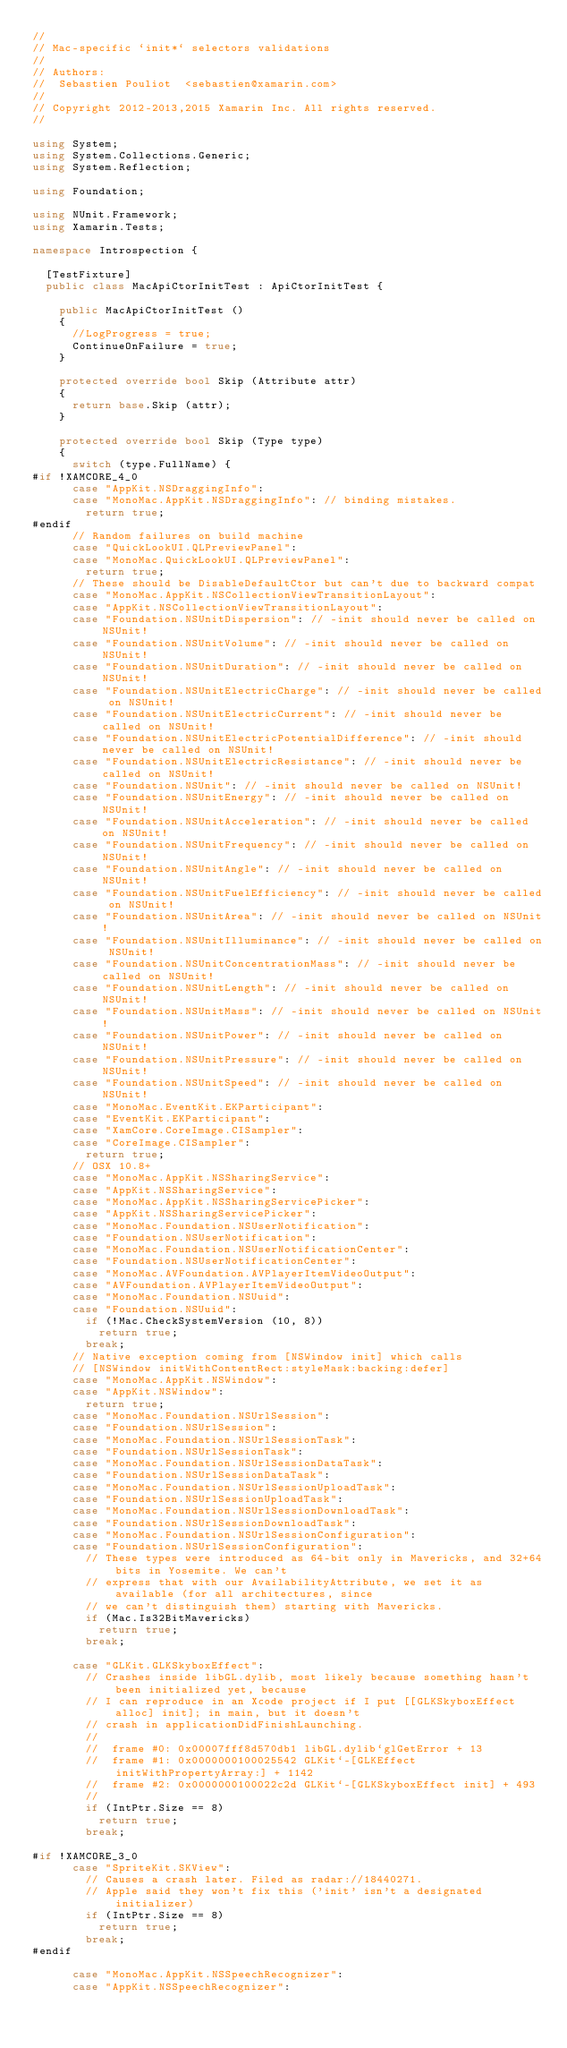Convert code to text. <code><loc_0><loc_0><loc_500><loc_500><_C#_>//
// Mac-specific `init*` selectors validations
//
// Authors:
//	Sebastien Pouliot  <sebastien@xamarin.com>
//
// Copyright 2012-2013,2015 Xamarin Inc. All rights reserved.
//

using System;
using System.Collections.Generic;
using System.Reflection;

using Foundation;

using NUnit.Framework;
using Xamarin.Tests;

namespace Introspection {

	[TestFixture]
	public class MacApiCtorInitTest : ApiCtorInitTest {

		public MacApiCtorInitTest ()
		{
			//LogProgress = true;
			ContinueOnFailure = true;
		}

		protected override bool Skip (Attribute attr)
		{
			return base.Skip (attr);
		}

		protected override bool Skip (Type type)
		{
			switch (type.FullName) {
#if !XAMCORE_4_0
			case "AppKit.NSDraggingInfo":
			case "MonoMac.AppKit.NSDraggingInfo": // binding mistakes.
				return true;
#endif
			// Random failures on build machine
			case "QuickLookUI.QLPreviewPanel":
			case "MonoMac.QuickLookUI.QLPreviewPanel":
				return true;
			// These should be DisableDefaultCtor but can't due to backward compat
			case "MonoMac.AppKit.NSCollectionViewTransitionLayout":
			case "AppKit.NSCollectionViewTransitionLayout":
			case "Foundation.NSUnitDispersion": // -init should never be called on NSUnit!
			case "Foundation.NSUnitVolume": // -init should never be called on NSUnit!
			case "Foundation.NSUnitDuration": // -init should never be called on NSUnit!
			case "Foundation.NSUnitElectricCharge": // -init should never be called on NSUnit!
			case "Foundation.NSUnitElectricCurrent": // -init should never be called on NSUnit!
			case "Foundation.NSUnitElectricPotentialDifference": // -init should never be called on NSUnit!
			case "Foundation.NSUnitElectricResistance": // -init should never be called on NSUnit!
			case "Foundation.NSUnit": // -init should never be called on NSUnit!
			case "Foundation.NSUnitEnergy": // -init should never be called on NSUnit!
			case "Foundation.NSUnitAcceleration": // -init should never be called on NSUnit!
			case "Foundation.NSUnitFrequency": // -init should never be called on NSUnit!
			case "Foundation.NSUnitAngle": // -init should never be called on NSUnit!
			case "Foundation.NSUnitFuelEfficiency": // -init should never be called on NSUnit!
			case "Foundation.NSUnitArea": // -init should never be called on NSUnit!
			case "Foundation.NSUnitIlluminance": // -init should never be called on NSUnit!
			case "Foundation.NSUnitConcentrationMass": // -init should never be called on NSUnit!
			case "Foundation.NSUnitLength": // -init should never be called on NSUnit!
			case "Foundation.NSUnitMass": // -init should never be called on NSUnit!
			case "Foundation.NSUnitPower": // -init should never be called on NSUnit!
			case "Foundation.NSUnitPressure": // -init should never be called on NSUnit!
			case "Foundation.NSUnitSpeed": // -init should never be called on NSUnit!
			case "MonoMac.EventKit.EKParticipant":
			case "EventKit.EKParticipant":
			case "XamCore.CoreImage.CISampler":
			case "CoreImage.CISampler":
				return true;
			// OSX 10.8+
			case "MonoMac.AppKit.NSSharingService":
			case "AppKit.NSSharingService":
			case "MonoMac.AppKit.NSSharingServicePicker":
			case "AppKit.NSSharingServicePicker":
			case "MonoMac.Foundation.NSUserNotification":
			case "Foundation.NSUserNotification":
			case "MonoMac.Foundation.NSUserNotificationCenter":
			case "Foundation.NSUserNotificationCenter":
			case "MonoMac.AVFoundation.AVPlayerItemVideoOutput":
			case "AVFoundation.AVPlayerItemVideoOutput":
			case "MonoMac.Foundation.NSUuid":
			case "Foundation.NSUuid":
				if (!Mac.CheckSystemVersion (10, 8))
					return true;
				break;
			// Native exception coming from [NSWindow init] which calls
			// [NSWindow initWithContentRect:styleMask:backing:defer]
			case "MonoMac.AppKit.NSWindow":
			case "AppKit.NSWindow":
				return true;
			case "MonoMac.Foundation.NSUrlSession":
			case "Foundation.NSUrlSession":
			case "MonoMac.Foundation.NSUrlSessionTask":
			case "Foundation.NSUrlSessionTask":
			case "MonoMac.Foundation.NSUrlSessionDataTask":
			case "Foundation.NSUrlSessionDataTask":
			case "MonoMac.Foundation.NSUrlSessionUploadTask":
			case "Foundation.NSUrlSessionUploadTask":
			case "MonoMac.Foundation.NSUrlSessionDownloadTask":
			case "Foundation.NSUrlSessionDownloadTask":
			case "MonoMac.Foundation.NSUrlSessionConfiguration":
			case "Foundation.NSUrlSessionConfiguration":
				// These types were introduced as 64-bit only in Mavericks, and 32+64bits in Yosemite. We can't
				// express that with our AvailabilityAttribute, we set it as available (for all architectures, since
				// we can't distinguish them) starting with Mavericks.
				if (Mac.Is32BitMavericks)
					return true;
				break;

			case "GLKit.GLKSkyboxEffect":
				// Crashes inside libGL.dylib, most likely because something hasn't been initialized yet, because
				// I can reproduce in an Xcode project if I put [[GLKSkyboxEffect alloc] init]; in main, but it doesn't
				// crash in applicationDidFinishLaunching.
				//
				//  frame #0: 0x00007fff8d570db1 libGL.dylib`glGetError + 13
				//  frame #1: 0x0000000100025542 GLKit`-[GLKEffect initWithPropertyArray:] + 1142
				//  frame #2: 0x0000000100022c2d GLKit`-[GLKSkyboxEffect init] + 493
				//
				if (IntPtr.Size == 8)
					return true;
				break;

#if !XAMCORE_3_0
			case "SpriteKit.SKView":
				// Causes a crash later. Filed as radar://18440271.
				// Apple said they won't fix this ('init' isn't a designated initializer)
				if (IntPtr.Size == 8)
					return true;
				break;
#endif

			case "MonoMac.AppKit.NSSpeechRecognizer":
			case "AppKit.NSSpeechRecognizer":</code> 